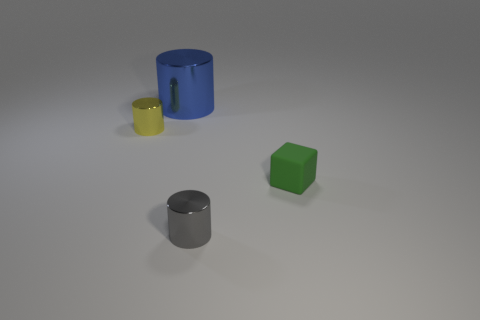What number of other objects are the same shape as the tiny gray object?
Keep it short and to the point. 2. There is a yellow object that is made of the same material as the small gray cylinder; what is its size?
Your answer should be very brief. Small. What is the color of the small cylinder that is on the left side of the small cylinder in front of the small rubber block?
Your answer should be very brief. Yellow. There is a tiny green rubber object; does it have the same shape as the small metallic object that is in front of the yellow thing?
Your response must be concise. No. What number of purple objects have the same size as the green object?
Give a very brief answer. 0. There is another small object that is the same shape as the yellow object; what is it made of?
Offer a very short reply. Metal. Does the small metallic cylinder in front of the rubber block have the same color as the small metal thing that is behind the tiny matte object?
Make the answer very short. No. What shape is the tiny object that is to the right of the gray object?
Your response must be concise. Cube. What color is the tiny rubber thing?
Your response must be concise. Green. What shape is the tiny yellow object that is made of the same material as the tiny gray cylinder?
Provide a short and direct response. Cylinder. 